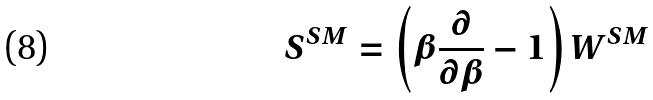Convert formula to latex. <formula><loc_0><loc_0><loc_500><loc_500>S ^ { S M } = \left ( \beta { \frac { \partial } { \partial \beta } } - 1 \right ) W ^ { S M }</formula> 